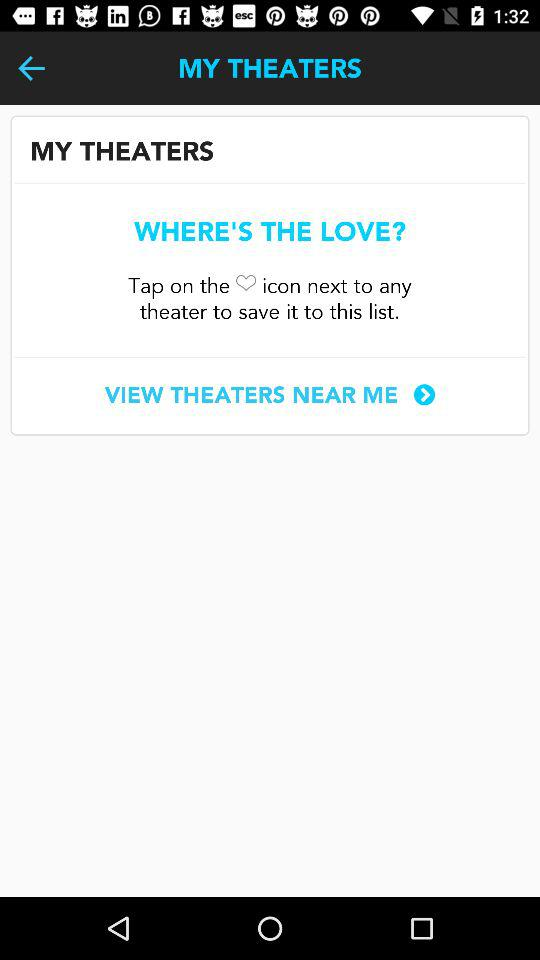What is the app name?
When the provided information is insufficient, respond with <no answer>. <no answer> 